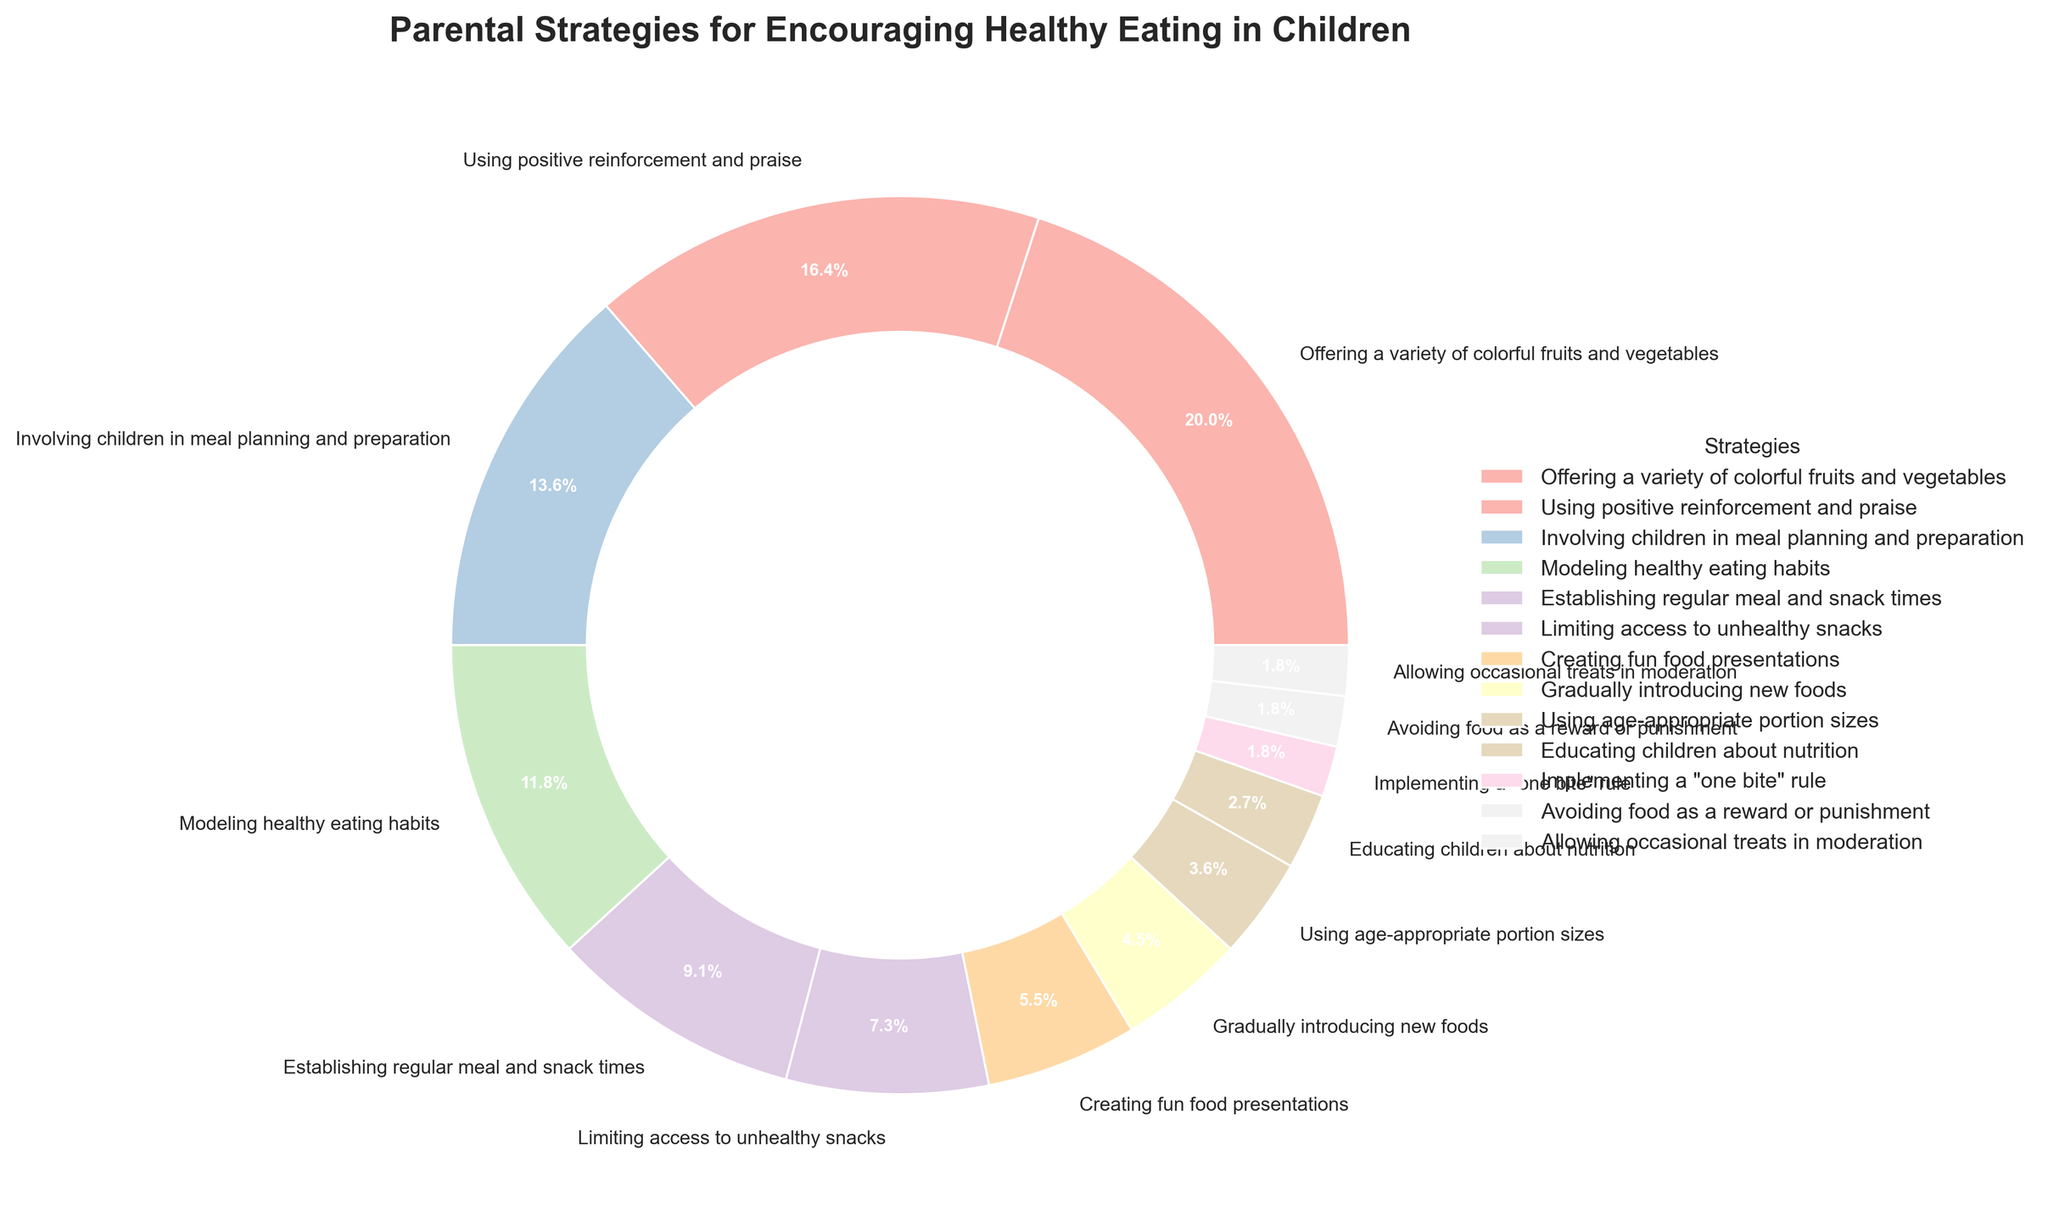Which strategy has the highest percentage? By observing the pie chart, the strategy with the largest section or percentage value should be identified. This is the segment offering a variety of colorful fruits and vegetables at 22%.
Answer: Offering a variety of colorful fruits and vegetables Which strategy contributes the least percentage? By looking for the smallest segment in the pie chart, which is indicated by the percentage values, we identify the strategy. This would be a few segments contributing 2% each: implementing a "one bite" rule, avoiding food as a reward or punishment, and allowing occasional treats in moderation.
Answer: Implementing a "one bite" rule, avoiding food as a reward or punishment, and allowing occasional treats in moderation What is the combined percentage of strategies that reinforce planning and structure? To identify the combined percentage, sum the percentages of strategies that relate to planning and structure. These include establishing regular meal and snack times (10%) and using age-appropriate portion sizes (4%), giving a total of 10% + 4% = 14%.
Answer: 14% How does the percentage of 'Modeling healthy eating habits' compare to 'Using positive reinforcement and praise'? To compare these two, directly compare their percentage values from the pie chart. The percentage for 'Modeling healthy eating habits' is 13%, which is less than 'Using positive reinforcement and praise' at 18%.
Answer: Less What is the total percentage of strategies that use some form of reinforcement? Sum the percentages of all strategies that imply any kind of reinforcement. These include using positive reinforcement and praise (18%) and creating fun food presentations (6%), which add up to 18% + 6% = 24%.
Answer: 24% Which strategy section is visually the largest in the pastel color palette of the pie chart? By looking at the visual size of the sections against the pastel color palette used, the largest section corresponds to the strategy offering a variety of colorful fruits and vegetables (22%).
Answer: Offering a variety of colorful fruits and vegetables How do the combined percentages of the top three strategies compare to half of the total chart? First, sum the percentages of the top three strategies: offering a variety of colorful fruits and vegetables (22%), using positive reinforcement and praise (18%), and involving children in meal planning and preparation (15%), which gives 22% + 18% + 15% = 55%. Compare this to 50% of the total chart. 55% is more than 50%.
Answer: More What is the difference in percentage between the strategy 'Limiting access to unhealthy snacks' and 'Creating fun food presentations'? Subtract the percentage of 'Creating fun food presentations' (6%) from 'Limiting access to unhealthy snacks' (8%) which is 8% - 6% = 2%.
Answer: 2% Which strategies fall within the range of 3% to 10% in terms of percentage? Identify segments within this range by observing the chart, which include establishing regular meal and snack times (10%), limiting access to unhealthy snacks (8%), creating fun food presentations (6%), and gradually introducing new foods (5%), educating children about nutrition (3%).
Answer: Establishing regular meal and snack times, limiting access to unhealthy snacks, creating fun food presentations, gradually introducing new foods, educating children about nutrition What percentage is attributed to strategies encouraging direct child involvement? Sum the percentages of strategies that directly involve the child. This includes involving children in meal planning and preparation (15%) and educating children about nutrition (3%), adding up to 15% + 3% = 18%.
Answer: 18% 